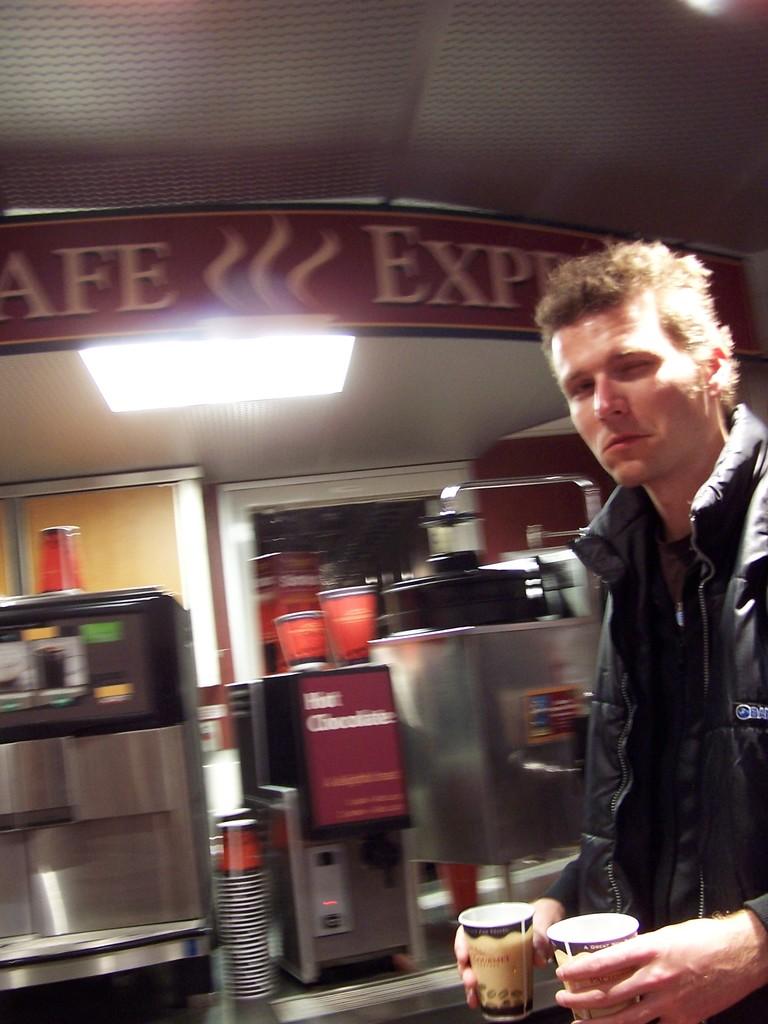How many cups is the man holding?
Your response must be concise. Answering does not require reading text in the image. What kind of chocolate is in the machine behind the man?
Ensure brevity in your answer.  Hot. 